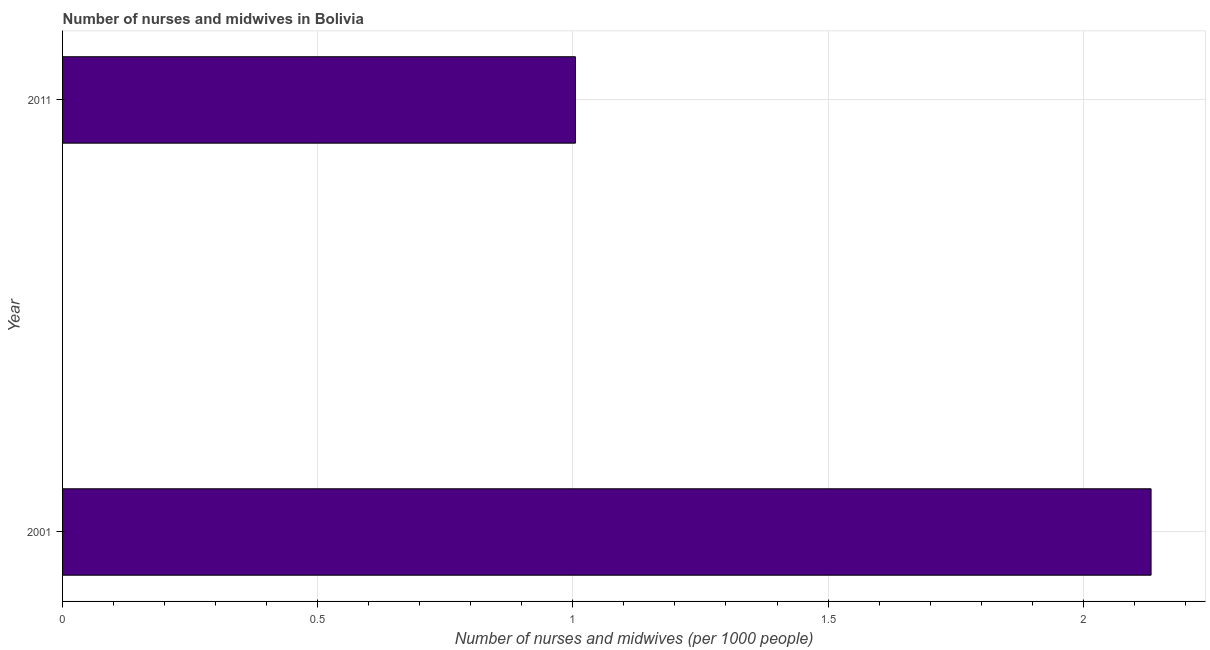Does the graph contain grids?
Offer a very short reply. Yes. What is the title of the graph?
Your answer should be compact. Number of nurses and midwives in Bolivia. What is the label or title of the X-axis?
Give a very brief answer. Number of nurses and midwives (per 1000 people). What is the label or title of the Y-axis?
Your answer should be compact. Year. What is the number of nurses and midwives in 2011?
Ensure brevity in your answer.  1. Across all years, what is the maximum number of nurses and midwives?
Your answer should be compact. 2.13. In which year was the number of nurses and midwives minimum?
Provide a succinct answer. 2011. What is the sum of the number of nurses and midwives?
Provide a succinct answer. 3.14. What is the difference between the number of nurses and midwives in 2001 and 2011?
Provide a succinct answer. 1.13. What is the average number of nurses and midwives per year?
Give a very brief answer. 1.57. What is the median number of nurses and midwives?
Provide a succinct answer. 1.57. In how many years, is the number of nurses and midwives greater than 0.7 ?
Offer a terse response. 2. Do a majority of the years between 2001 and 2011 (inclusive) have number of nurses and midwives greater than 1.7 ?
Your answer should be compact. No. What is the ratio of the number of nurses and midwives in 2001 to that in 2011?
Keep it short and to the point. 2.12. In how many years, is the number of nurses and midwives greater than the average number of nurses and midwives taken over all years?
Offer a very short reply. 1. Are all the bars in the graph horizontal?
Your answer should be very brief. Yes. How many years are there in the graph?
Make the answer very short. 2. What is the difference between two consecutive major ticks on the X-axis?
Your answer should be very brief. 0.5. Are the values on the major ticks of X-axis written in scientific E-notation?
Make the answer very short. No. What is the Number of nurses and midwives (per 1000 people) in 2001?
Keep it short and to the point. 2.13. What is the difference between the Number of nurses and midwives (per 1000 people) in 2001 and 2011?
Keep it short and to the point. 1.13. What is the ratio of the Number of nurses and midwives (per 1000 people) in 2001 to that in 2011?
Give a very brief answer. 2.12. 